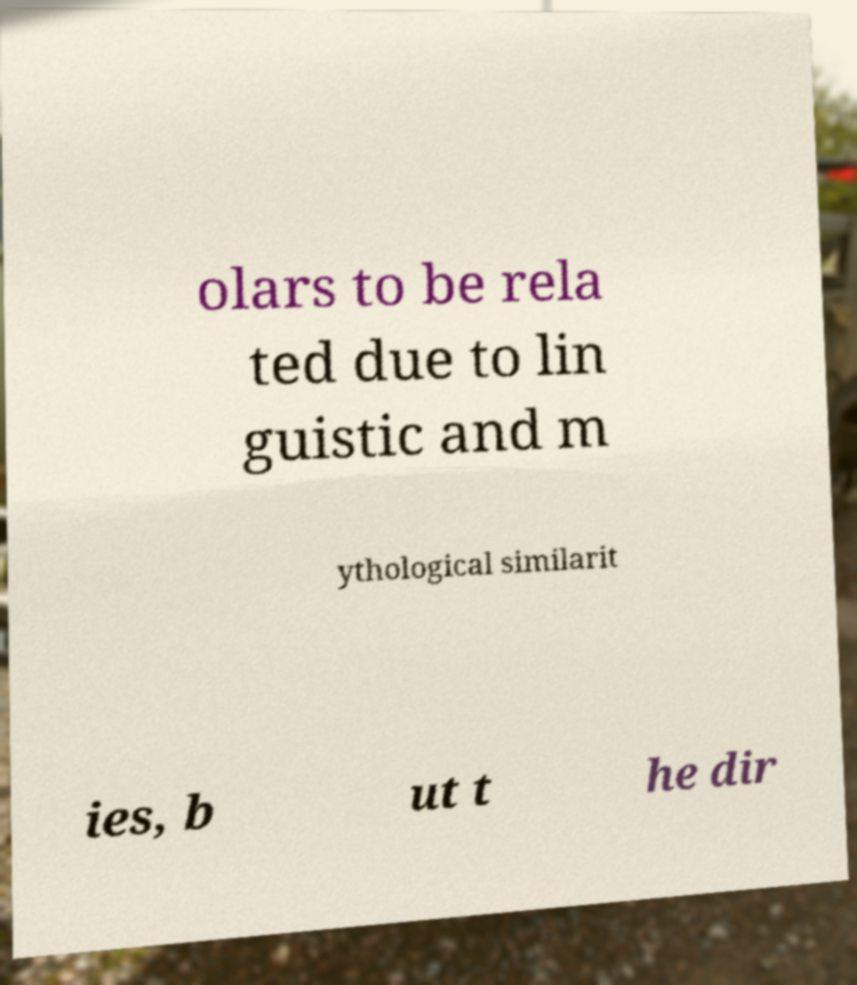Can you accurately transcribe the text from the provided image for me? olars to be rela ted due to lin guistic and m ythological similarit ies, b ut t he dir 